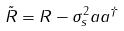<formula> <loc_0><loc_0><loc_500><loc_500>\tilde { R } = R - \sigma _ { s } ^ { 2 } a a ^ { \dagger }</formula> 